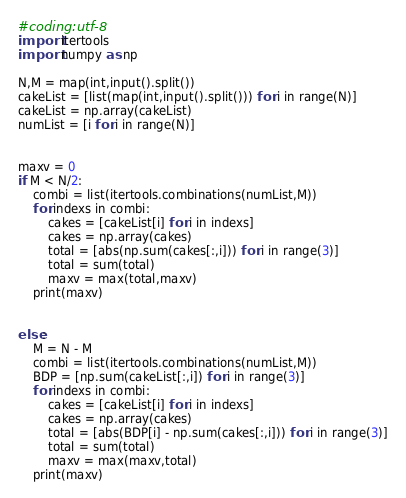Convert code to text. <code><loc_0><loc_0><loc_500><loc_500><_Python_>#coding:utf-8
import itertools
import numpy as np

N,M = map(int,input().split())
cakeList = [list(map(int,input().split())) for i in range(N)]
cakeList = np.array(cakeList)
numList = [i for i in range(N)]


maxv = 0
if M < N/2:
    combi = list(itertools.combinations(numList,M))
    for indexs in combi:
        cakes = [cakeList[i] for i in indexs]
        cakes = np.array(cakes)
        total = [abs(np.sum(cakes[:,i])) for i in range(3)]
        total = sum(total)
        maxv = max(total,maxv)
    print(maxv)


else:
    M = N - M
    combi = list(itertools.combinations(numList,M))
    BDP = [np.sum(cakeList[:,i]) for i in range(3)]
    for indexs in combi:
        cakes = [cakeList[i] for i in indexs]
        cakes = np.array(cakes)
        total = [abs(BDP[i] - np.sum(cakes[:,i])) for i in range(3)]
        total = sum(total)
        maxv = max(maxv,total)
    print(maxv)
</code> 